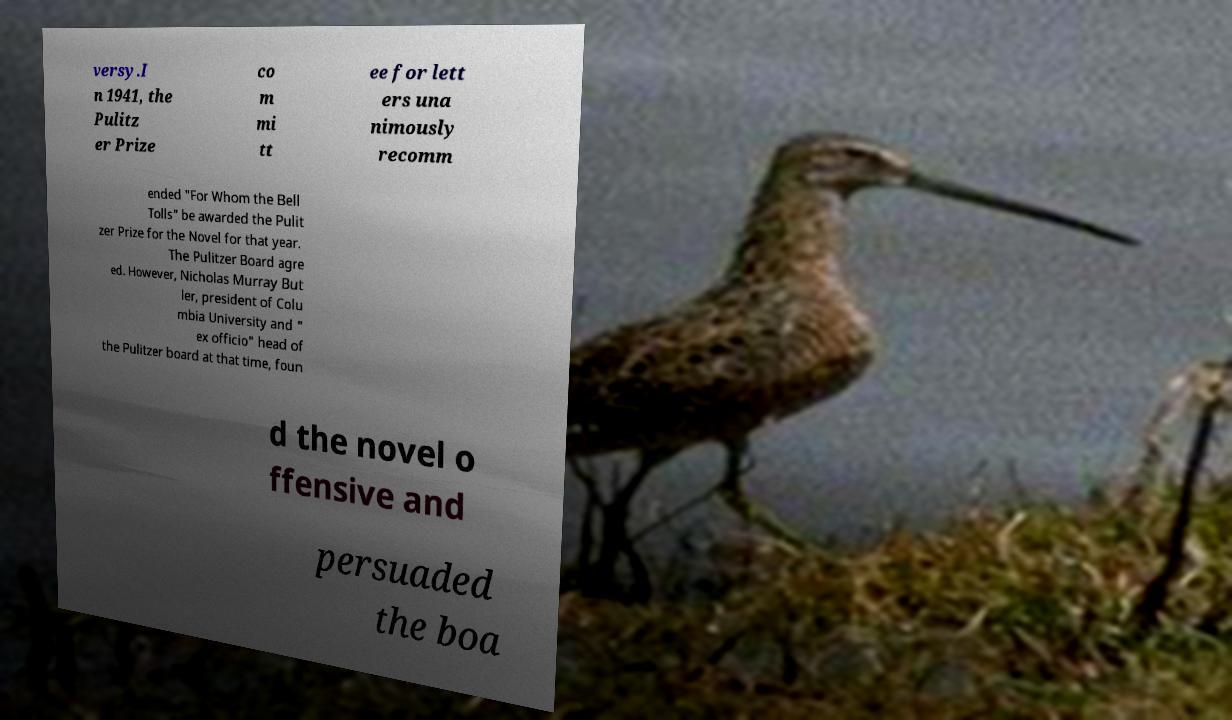Please read and relay the text visible in this image. What does it say? versy.I n 1941, the Pulitz er Prize co m mi tt ee for lett ers una nimously recomm ended "For Whom the Bell Tolls" be awarded the Pulit zer Prize for the Novel for that year. The Pulitzer Board agre ed. However, Nicholas Murray But ler, president of Colu mbia University and " ex officio" head of the Pulitzer board at that time, foun d the novel o ffensive and persuaded the boa 